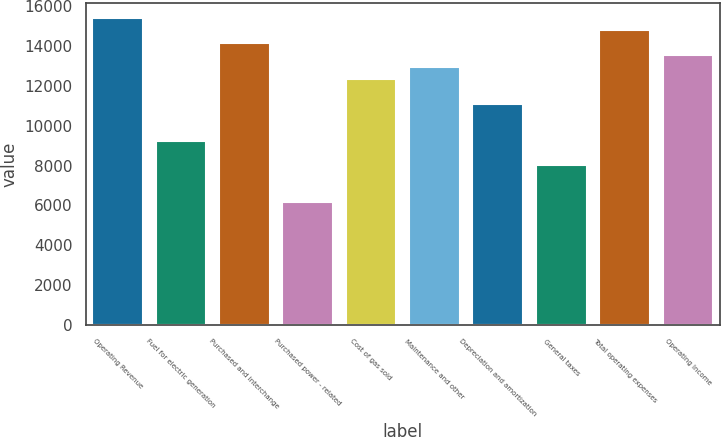<chart> <loc_0><loc_0><loc_500><loc_500><bar_chart><fcel>Operating Revenue<fcel>Fuel for electric generation<fcel>Purchased and interchange<fcel>Purchased power - related<fcel>Cost of gas sold<fcel>Maintenance and other<fcel>Depreciation and amortization<fcel>General taxes<fcel>Total operating expenses<fcel>Operating Income<nl><fcel>15411<fcel>9247<fcel>14178.2<fcel>6165<fcel>12329<fcel>12945.4<fcel>11096.2<fcel>8014.2<fcel>14794.6<fcel>13561.8<nl></chart> 